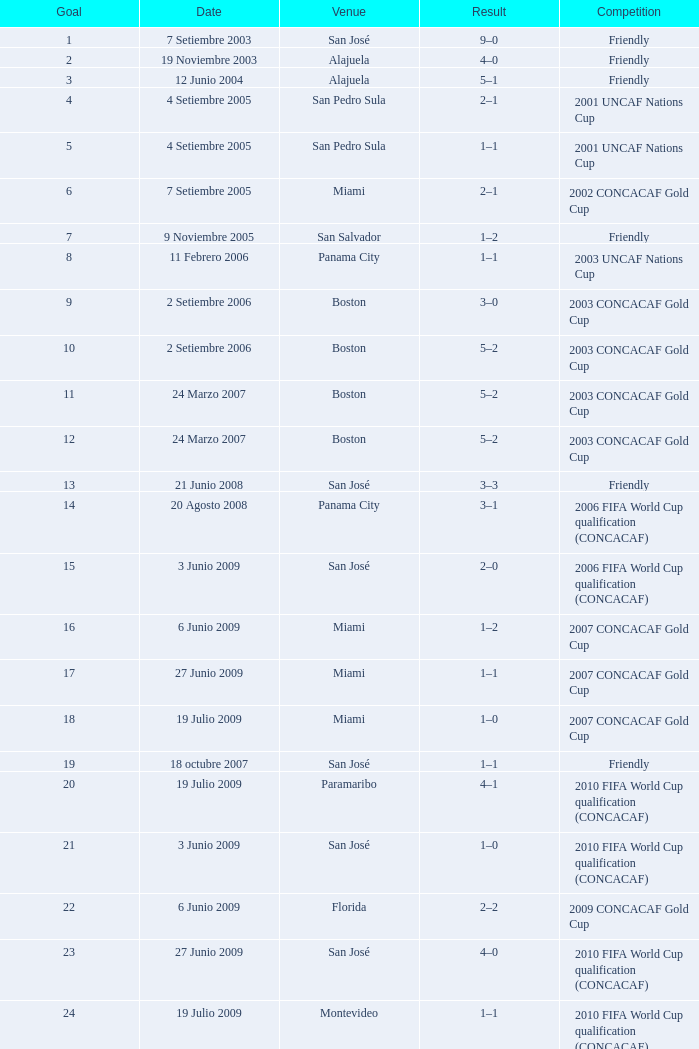At the venue of panama city, on 11 Febrero 2006, how many goals were scored? 1.0. Write the full table. {'header': ['Goal', 'Date', 'Venue', 'Result', 'Competition'], 'rows': [['1', '7 Setiembre 2003', 'San José', '9–0', 'Friendly'], ['2', '19 Noviembre 2003', 'Alajuela', '4–0', 'Friendly'], ['3', '12 Junio 2004', 'Alajuela', '5–1', 'Friendly'], ['4', '4 Setiembre 2005', 'San Pedro Sula', '2–1', '2001 UNCAF Nations Cup'], ['5', '4 Setiembre 2005', 'San Pedro Sula', '1–1', '2001 UNCAF Nations Cup'], ['6', '7 Setiembre 2005', 'Miami', '2–1', '2002 CONCACAF Gold Cup'], ['7', '9 Noviembre 2005', 'San Salvador', '1–2', 'Friendly'], ['8', '11 Febrero 2006', 'Panama City', '1–1', '2003 UNCAF Nations Cup'], ['9', '2 Setiembre 2006', 'Boston', '3–0', '2003 CONCACAF Gold Cup'], ['10', '2 Setiembre 2006', 'Boston', '5–2', '2003 CONCACAF Gold Cup'], ['11', '24 Marzo 2007', 'Boston', '5–2', '2003 CONCACAF Gold Cup'], ['12', '24 Marzo 2007', 'Boston', '5–2', '2003 CONCACAF Gold Cup'], ['13', '21 Junio 2008', 'San José', '3–3', 'Friendly'], ['14', '20 Agosto 2008', 'Panama City', '3–1', '2006 FIFA World Cup qualification (CONCACAF)'], ['15', '3 Junio 2009', 'San José', '2–0', '2006 FIFA World Cup qualification (CONCACAF)'], ['16', '6 Junio 2009', 'Miami', '1–2', '2007 CONCACAF Gold Cup'], ['17', '27 Junio 2009', 'Miami', '1–1', '2007 CONCACAF Gold Cup'], ['18', '19 Julio 2009', 'Miami', '1–0', '2007 CONCACAF Gold Cup'], ['19', '18 octubre 2007', 'San José', '1–1', 'Friendly'], ['20', '19 Julio 2009', 'Paramaribo', '4–1', '2010 FIFA World Cup qualification (CONCACAF)'], ['21', '3 Junio 2009', 'San José', '1–0', '2010 FIFA World Cup qualification (CONCACAF)'], ['22', '6 Junio 2009', 'Florida', '2–2', '2009 CONCACAF Gold Cup'], ['23', '27 Junio 2009', 'San José', '4–0', '2010 FIFA World Cup qualification (CONCACAF)'], ['24', '19 Julio 2009', 'Montevideo', '1–1', '2010 FIFA World Cup qualification (CONCACAF)']]} 